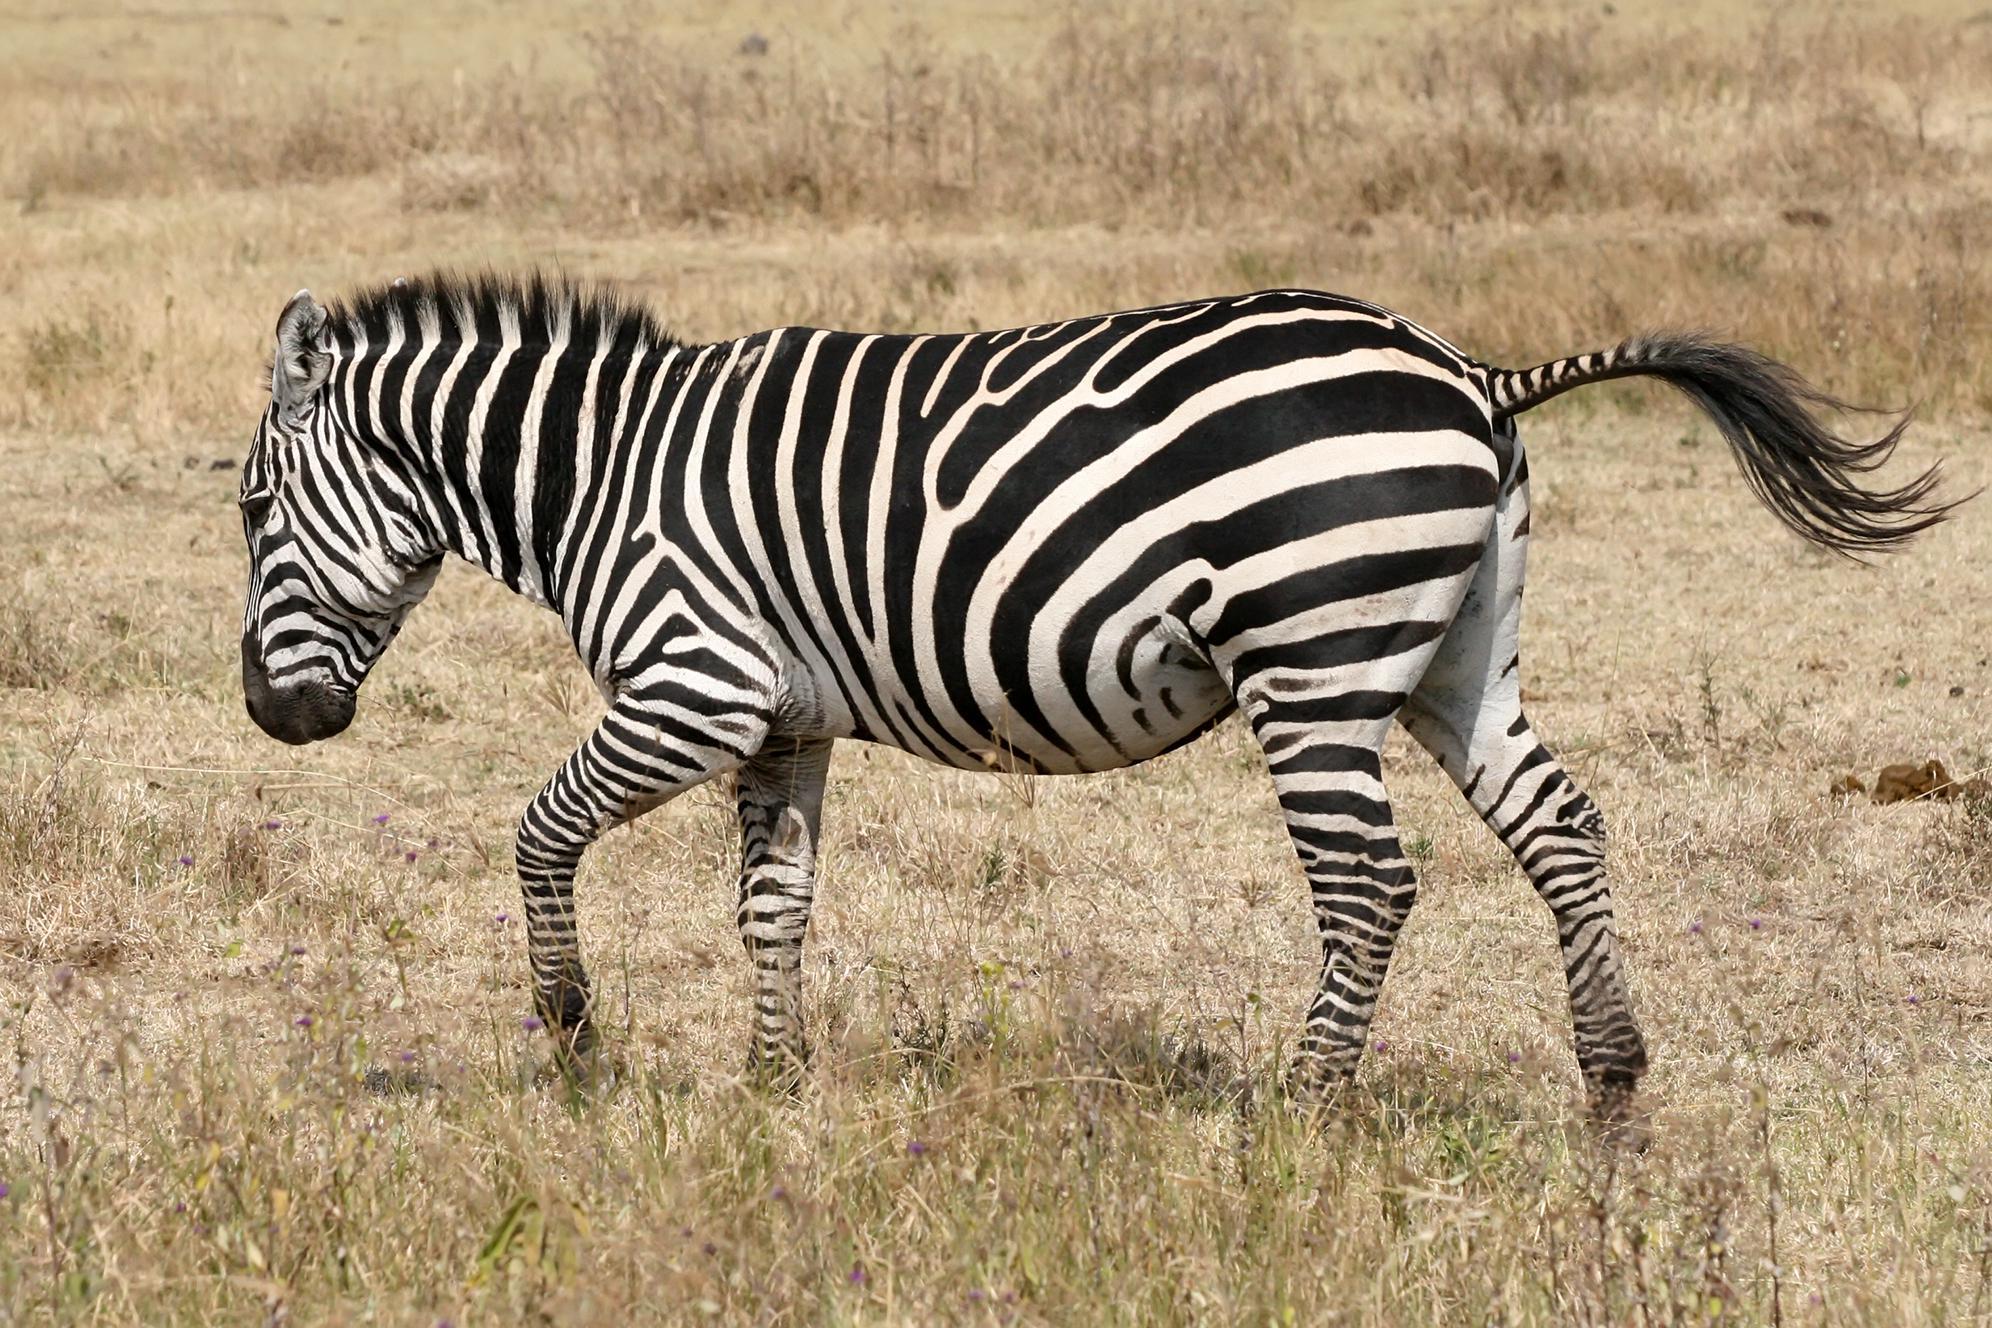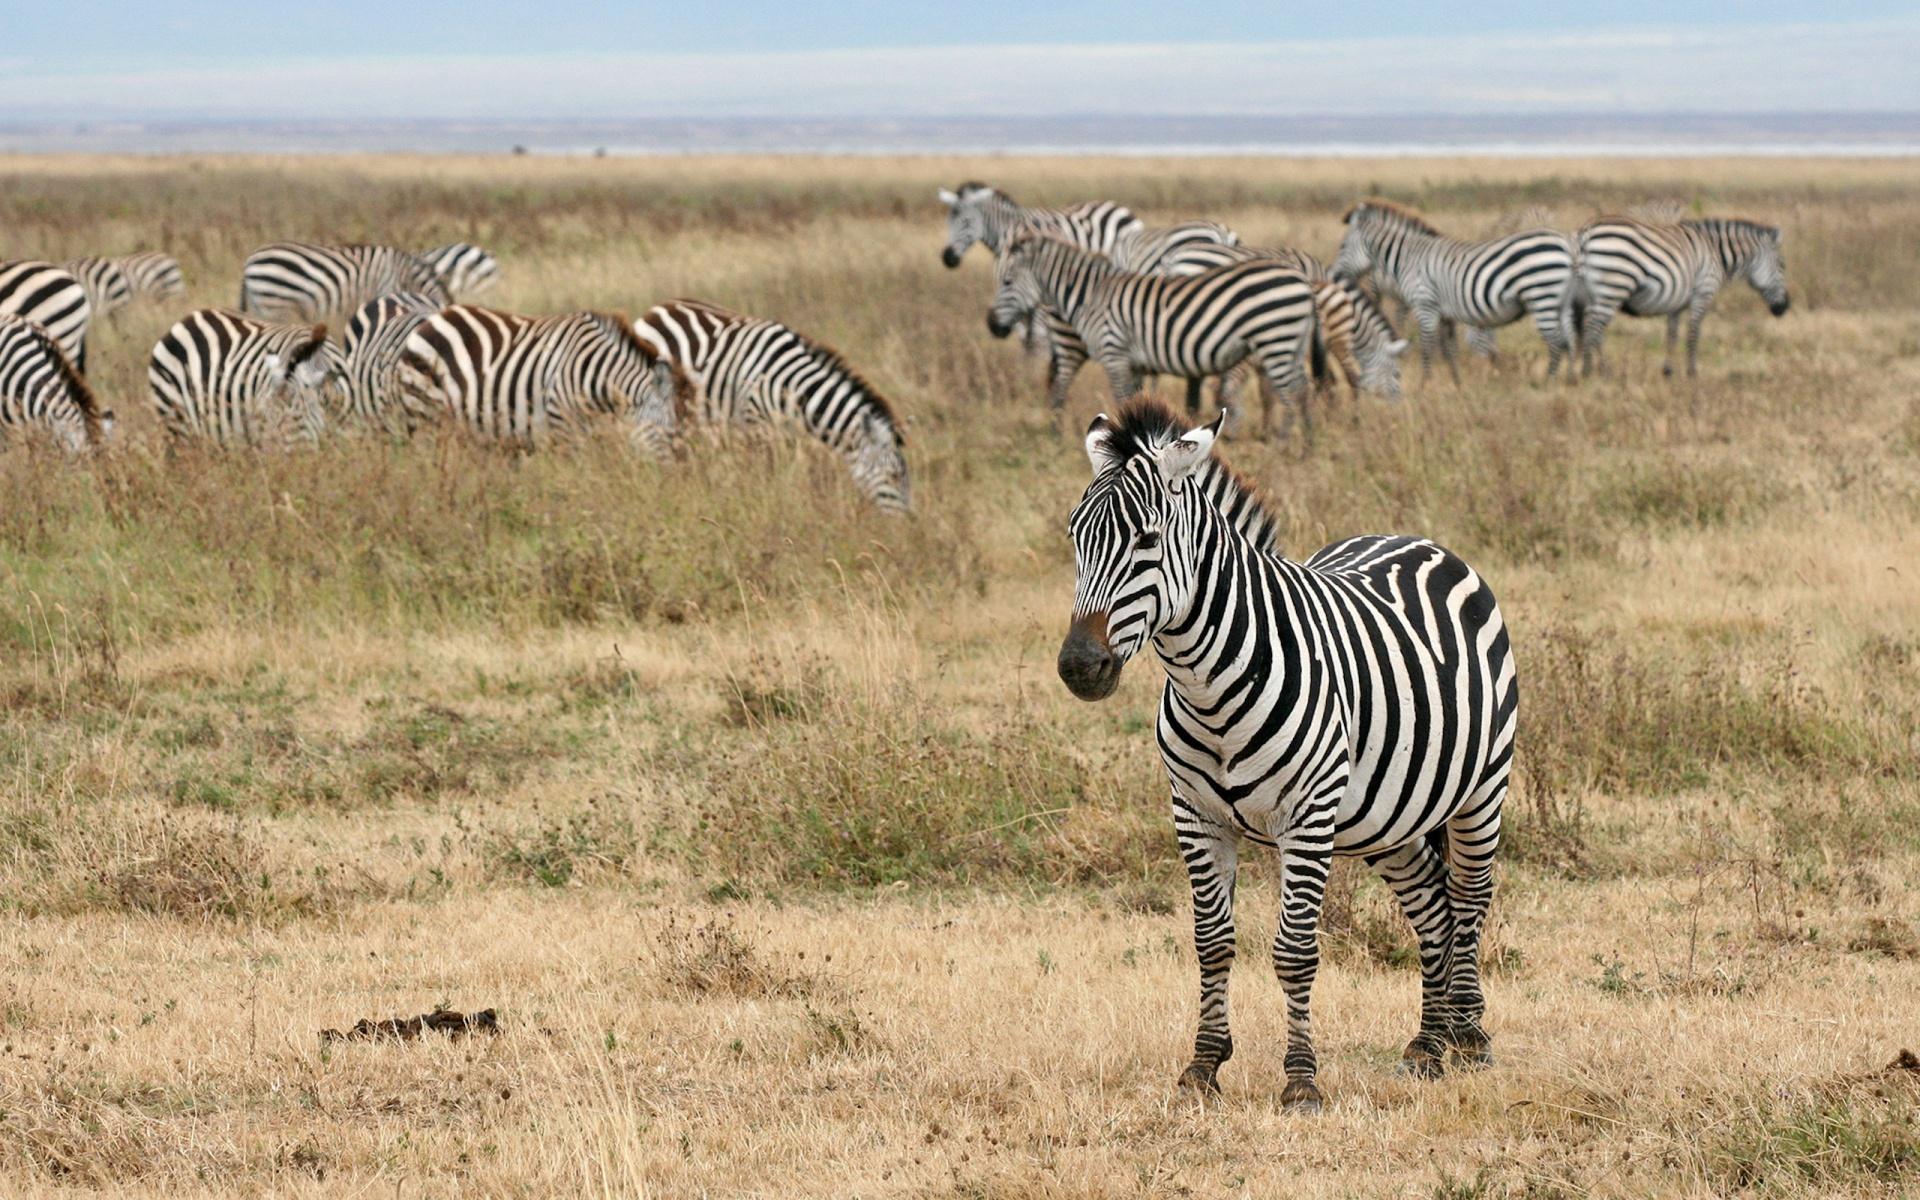The first image is the image on the left, the second image is the image on the right. For the images displayed, is the sentence "One of the images shows exactly one zebra, while the other image shows exactly two which have a brown tint to their coloring." factually correct? Answer yes or no. No. The first image is the image on the left, the second image is the image on the right. Considering the images on both sides, is "There are two zebras in the left image." valid? Answer yes or no. No. 